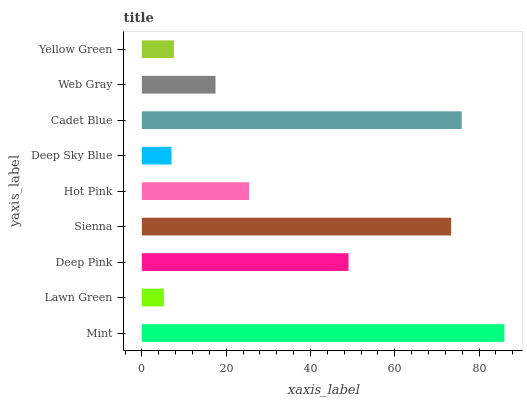Is Lawn Green the minimum?
Answer yes or no. Yes. Is Mint the maximum?
Answer yes or no. Yes. Is Deep Pink the minimum?
Answer yes or no. No. Is Deep Pink the maximum?
Answer yes or no. No. Is Deep Pink greater than Lawn Green?
Answer yes or no. Yes. Is Lawn Green less than Deep Pink?
Answer yes or no. Yes. Is Lawn Green greater than Deep Pink?
Answer yes or no. No. Is Deep Pink less than Lawn Green?
Answer yes or no. No. Is Hot Pink the high median?
Answer yes or no. Yes. Is Hot Pink the low median?
Answer yes or no. Yes. Is Sienna the high median?
Answer yes or no. No. Is Deep Pink the low median?
Answer yes or no. No. 